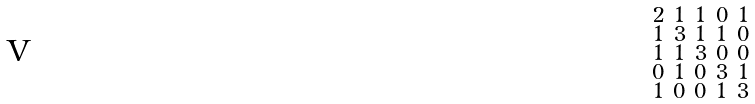<formula> <loc_0><loc_0><loc_500><loc_500>\begin{smallmatrix} 2 & 1 & 1 & 0 & 1 \\ 1 & 3 & 1 & 1 & 0 \\ 1 & 1 & 3 & 0 & 0 \\ 0 & 1 & 0 & 3 & 1 \\ 1 & 0 & 0 & 1 & 3 \end{smallmatrix}</formula> 